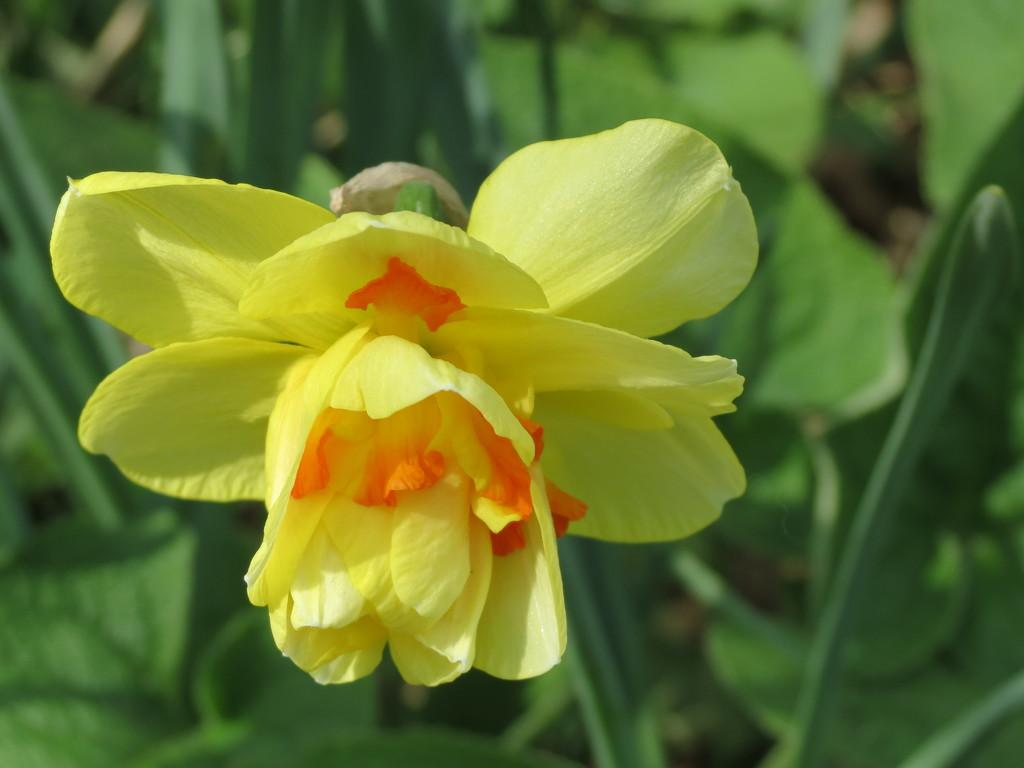What is the main subject of the image? There is a yellow color flower in the center of the image. What color are the leaves surrounding the flower? The leaves in the background of the image are green. What else can be seen in the background of the image? There are other objects visible in the background of the image. What type of wine is being served in the image? There is no wine present in the image; it features a yellow flower and green leaves. Is there a cabbage growing next to the flower in the image? There is no cabbage visible in the image; it only shows a yellow flower and green leaves. 